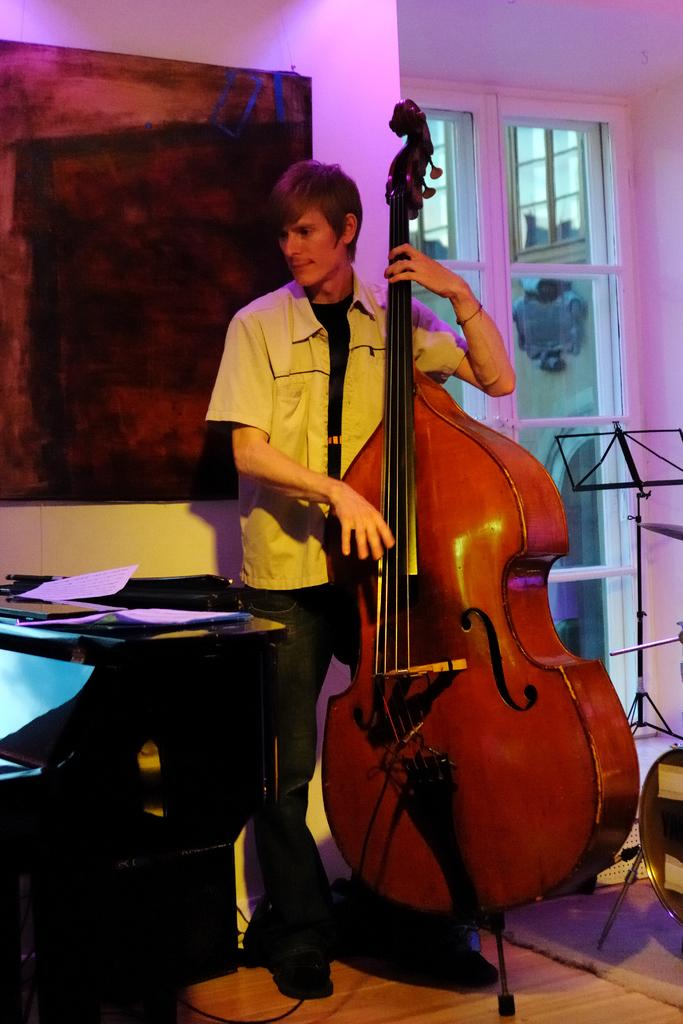What is the main subject of the image? The main subject of the image is a man. What is the man holding in his hand? The man is holding a big violin in his hand. What type of flag is the man holding in the image? There is no flag present in the image; the man is holding a big violin. 